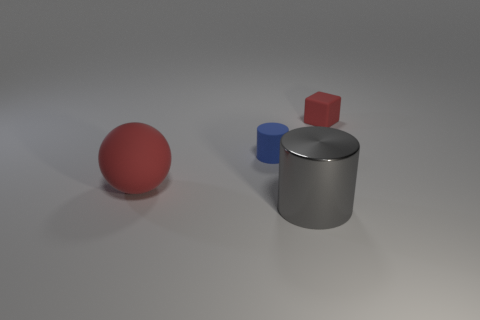Add 2 gray cylinders. How many objects exist? 6 Subtract all balls. How many objects are left? 3 Add 2 tiny red cubes. How many tiny red cubes exist? 3 Subtract 0 yellow cylinders. How many objects are left? 4 Subtract all rubber spheres. Subtract all purple matte things. How many objects are left? 3 Add 2 large cylinders. How many large cylinders are left? 3 